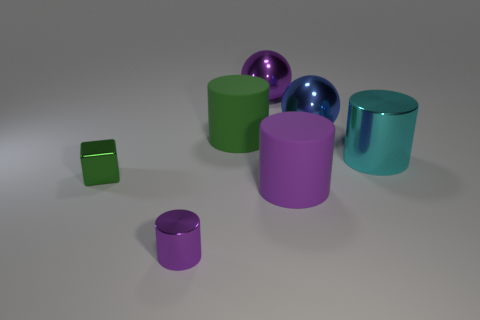Is there any other thing of the same color as the large metallic cylinder?
Keep it short and to the point. No. Is the number of rubber cylinders less than the number of purple objects?
Offer a very short reply. Yes. The shiny thing that is the same size as the purple metal cylinder is what shape?
Your answer should be compact. Cube. What number of other things are the same color as the tiny metal block?
Offer a very short reply. 1. What number of small yellow matte cylinders are there?
Your response must be concise. 0. What number of cylinders are both to the left of the big cyan shiny thing and behind the green metallic object?
Provide a succinct answer. 1. What is the material of the large purple cylinder?
Keep it short and to the point. Rubber. Is there a tiny brown shiny cylinder?
Your answer should be very brief. No. What is the color of the metallic cylinder behind the small green object?
Provide a succinct answer. Cyan. How many large spheres are behind the green thing on the right side of the purple shiny object that is in front of the big green matte cylinder?
Ensure brevity in your answer.  2. 